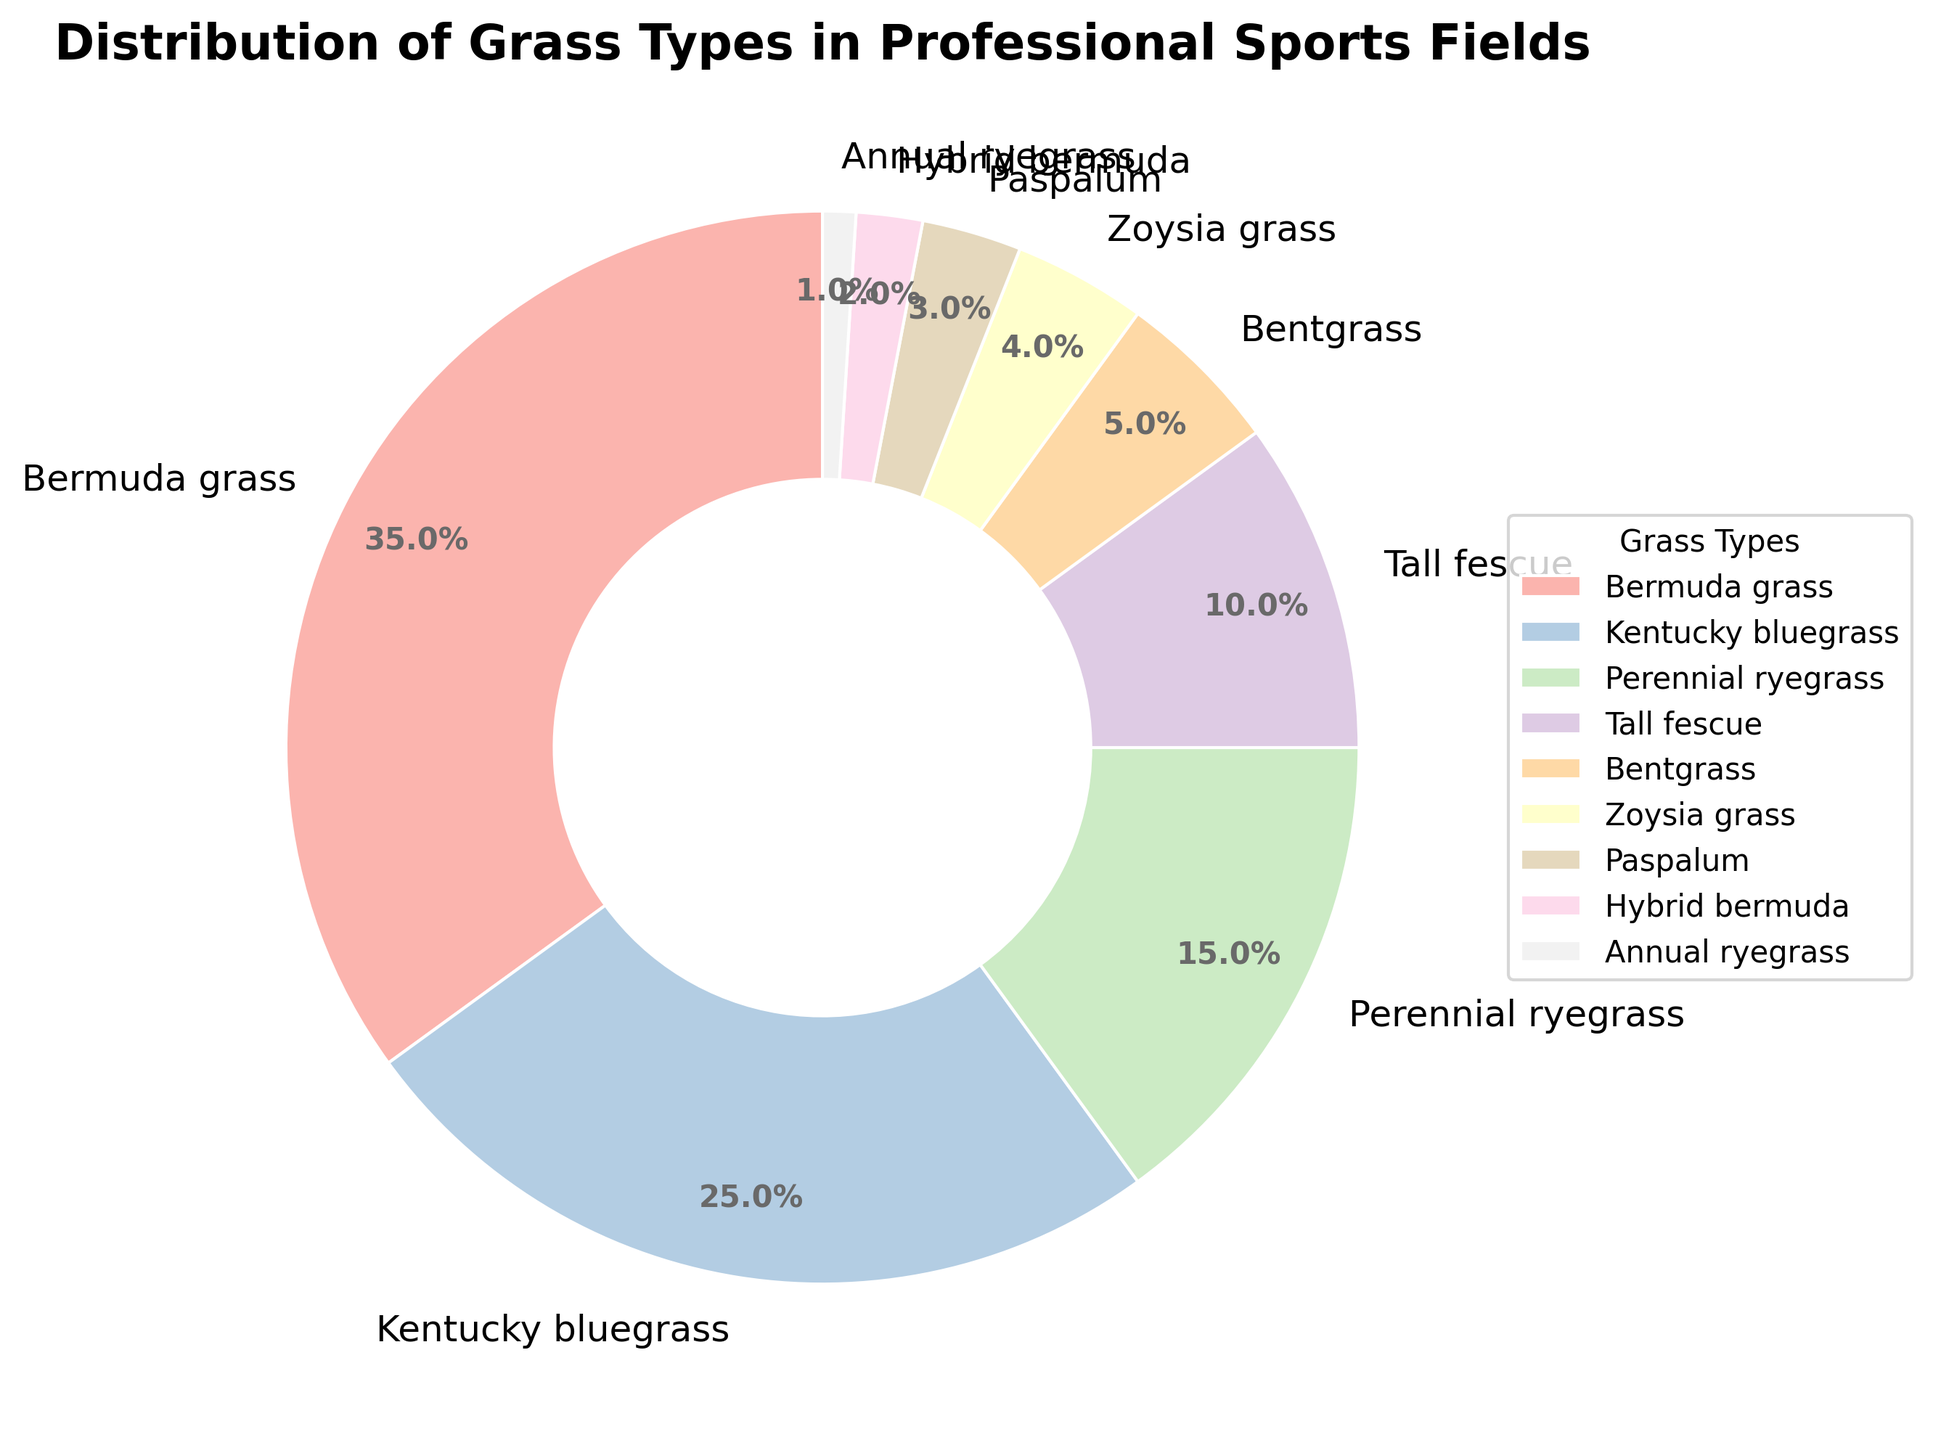Which grass type is the most commonly used in professional sports fields? The pie chart shows that Bermuda grass has the largest segment, representing 35% of the distribution.
Answer: Bermuda grass What is the combined percentage of Kentucky bluegrass and Perennial ryegrass? Kentucky bluegrass represents 25% and Perennial ryegrass represents 15%. Adding these together gives 25% + 15% = 40%.
Answer: 40% How does the percentage of Bentgrass compare to that of Tall fescue? Bentgrass has a segment representing 5%, while Tall fescue has a segment representing 10%. Bentgrass is half the percentage of Tall fescue.
Answer: 5% vs 10% Which grass type has a smaller percentage, Zoysia grass or Paspalum? Zoysia grass is represented by 4%, while Paspalum is represented by 3%. Therefore, Paspalum has a smaller percentage.
Answer: Paspalum How many different grass types make up less than 5% each of the total? Bentgrass (5%), Zoysia grass (4%), Paspalum (3%), Hybrid Bermuda (2%), and Annual Ryegrass (1%) are the categories listed, but we need those under 5%. So, Zoysia grass, Paspalum, Hybrid Bermuda, and Annual Ryegrass are under 5%. Counting these gives us 4 types.
Answer: 4 What is the total percentage covered by grass types other than Bermuda grass and Kentucky bluegrass? The percentages of other grass types are: Perennial ryegrass (15%), Tall fescue (10%), Bentgrass (5%), Zoysia grass (4%), Paspalum (3%), Hybrid bermuda (2%), and Annual ryegrass (1%). Adding these together: 15% + 10% + 5% + 4% + 3% + 2% + 1% = 40%.
Answer: 40% Which grass type is least commonly used in professional sports fields? The smallest segment represents Annual ryegrass, which constitutes 1% of the distribution.
Answer: Annual ryegrass By how much does the percentage of Kentucky bluegrass exceed that of Paspalum? Kentucky bluegrass is 25% while Paspalum is 3%. Subtracting these, we get 25% - 3% = 22%.
Answer: 22% Which grass types constitute exactly 15% or more of the distribution? The grass types with segments 15% or more are Bermuda grass (35%), Kentucky bluegrass (25%), and Perennial ryegrass (15%).
Answer: 3 